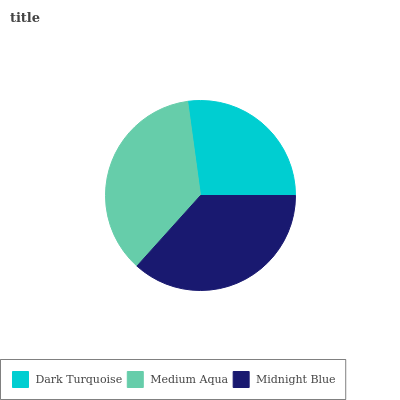Is Dark Turquoise the minimum?
Answer yes or no. Yes. Is Midnight Blue the maximum?
Answer yes or no. Yes. Is Medium Aqua the minimum?
Answer yes or no. No. Is Medium Aqua the maximum?
Answer yes or no. No. Is Medium Aqua greater than Dark Turquoise?
Answer yes or no. Yes. Is Dark Turquoise less than Medium Aqua?
Answer yes or no. Yes. Is Dark Turquoise greater than Medium Aqua?
Answer yes or no. No. Is Medium Aqua less than Dark Turquoise?
Answer yes or no. No. Is Medium Aqua the high median?
Answer yes or no. Yes. Is Medium Aqua the low median?
Answer yes or no. Yes. Is Dark Turquoise the high median?
Answer yes or no. No. Is Midnight Blue the low median?
Answer yes or no. No. 